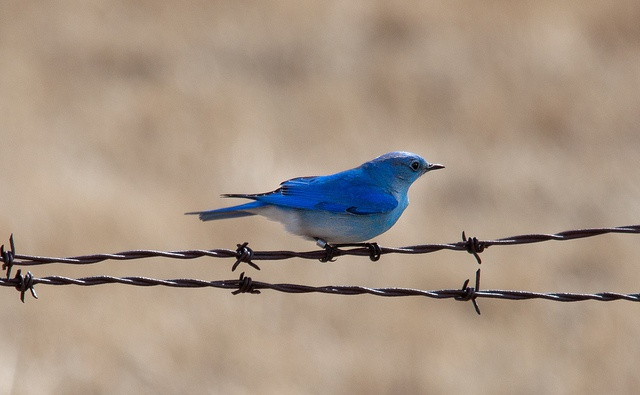Describe the objects in this image and their specific colors. I can see a bird in tan, blue, gray, and navy tones in this image. 